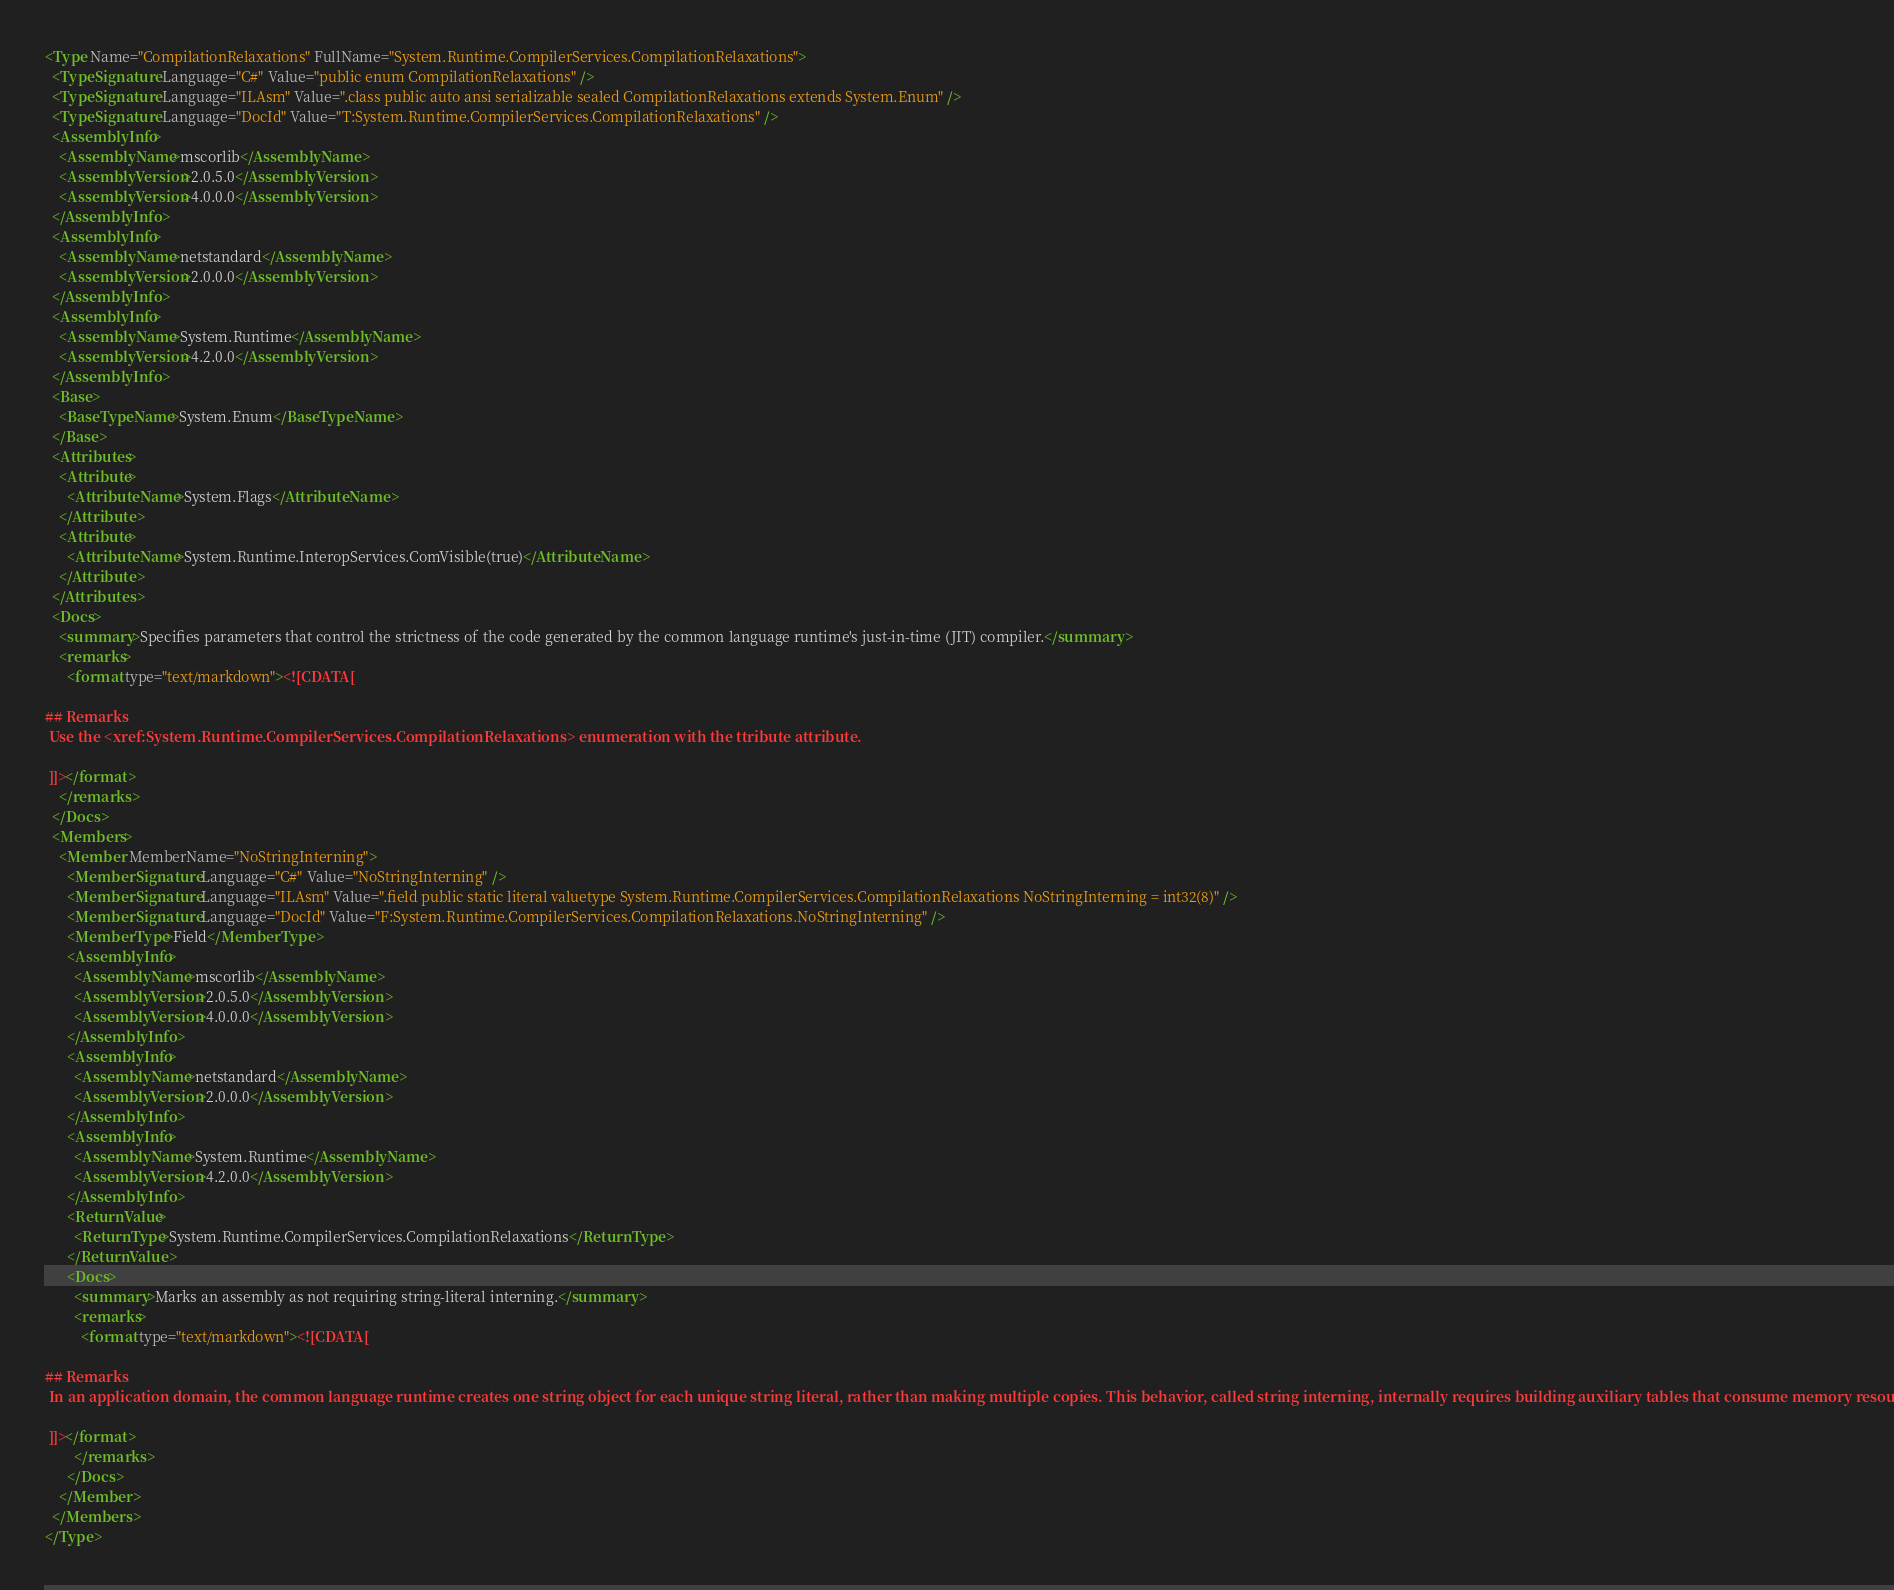Convert code to text. <code><loc_0><loc_0><loc_500><loc_500><_XML_><Type Name="CompilationRelaxations" FullName="System.Runtime.CompilerServices.CompilationRelaxations">
  <TypeSignature Language="C#" Value="public enum CompilationRelaxations" />
  <TypeSignature Language="ILAsm" Value=".class public auto ansi serializable sealed CompilationRelaxations extends System.Enum" />
  <TypeSignature Language="DocId" Value="T:System.Runtime.CompilerServices.CompilationRelaxations" />
  <AssemblyInfo>
    <AssemblyName>mscorlib</AssemblyName>
    <AssemblyVersion>2.0.5.0</AssemblyVersion>
    <AssemblyVersion>4.0.0.0</AssemblyVersion>
  </AssemblyInfo>
  <AssemblyInfo>
    <AssemblyName>netstandard</AssemblyName>
    <AssemblyVersion>2.0.0.0</AssemblyVersion>
  </AssemblyInfo>
  <AssemblyInfo>
    <AssemblyName>System.Runtime</AssemblyName>
    <AssemblyVersion>4.2.0.0</AssemblyVersion>
  </AssemblyInfo>
  <Base>
    <BaseTypeName>System.Enum</BaseTypeName>
  </Base>
  <Attributes>
    <Attribute>
      <AttributeName>System.Flags</AttributeName>
    </Attribute>
    <Attribute>
      <AttributeName>System.Runtime.InteropServices.ComVisible(true)</AttributeName>
    </Attribute>
  </Attributes>
  <Docs>
    <summary>Specifies parameters that control the strictness of the code generated by the common language runtime's just-in-time (JIT) compiler.</summary>
    <remarks>
      <format type="text/markdown"><![CDATA[  
  
## Remarks  
 Use the <xref:System.Runtime.CompilerServices.CompilationRelaxations> enumeration with the ttribute attribute.  
  
 ]]></format>
    </remarks>
  </Docs>
  <Members>
    <Member MemberName="NoStringInterning">
      <MemberSignature Language="C#" Value="NoStringInterning" />
      <MemberSignature Language="ILAsm" Value=".field public static literal valuetype System.Runtime.CompilerServices.CompilationRelaxations NoStringInterning = int32(8)" />
      <MemberSignature Language="DocId" Value="F:System.Runtime.CompilerServices.CompilationRelaxations.NoStringInterning" />
      <MemberType>Field</MemberType>
      <AssemblyInfo>
        <AssemblyName>mscorlib</AssemblyName>
        <AssemblyVersion>2.0.5.0</AssemblyVersion>
        <AssemblyVersion>4.0.0.0</AssemblyVersion>
      </AssemblyInfo>
      <AssemblyInfo>
        <AssemblyName>netstandard</AssemblyName>
        <AssemblyVersion>2.0.0.0</AssemblyVersion>
      </AssemblyInfo>
      <AssemblyInfo>
        <AssemblyName>System.Runtime</AssemblyName>
        <AssemblyVersion>4.2.0.0</AssemblyVersion>
      </AssemblyInfo>
      <ReturnValue>
        <ReturnType>System.Runtime.CompilerServices.CompilationRelaxations</ReturnType>
      </ReturnValue>
      <Docs>
        <summary>Marks an assembly as not requiring string-literal interning.</summary>
        <remarks>
          <format type="text/markdown"><![CDATA[  
  
## Remarks  
 In an application domain, the common language runtime creates one string object for each unique string literal, rather than making multiple copies. This behavior, called string interning, internally requires building auxiliary tables that consume memory resources.  
  
 ]]></format>
        </remarks>
      </Docs>
    </Member>
  </Members>
</Type>
</code> 